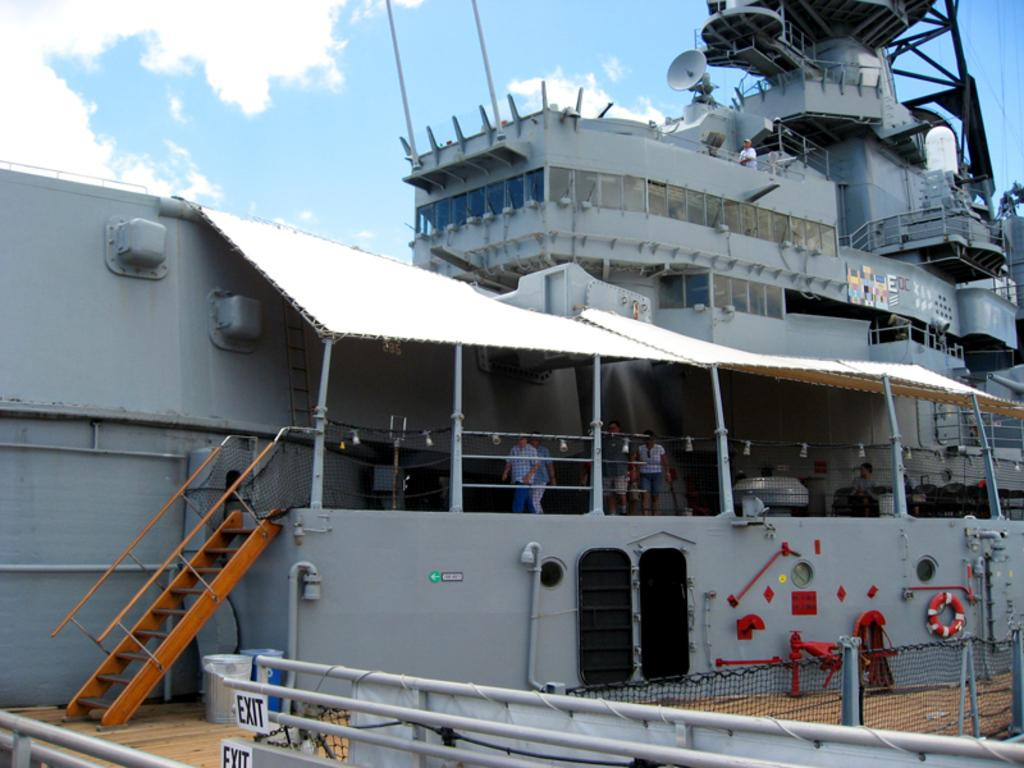<image>
Give a short and clear explanation of the subsequent image. Large ship with stairs and a sign which leads to the EXIT. 